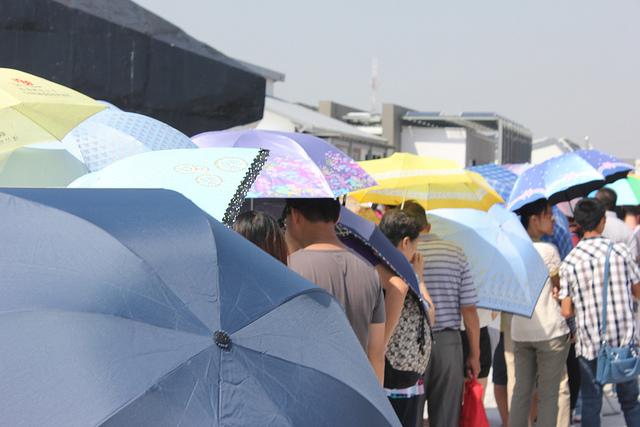How many umbrellas are here?
Be succinct. 10. Are there men and women in the picture?
Write a very short answer. Yes. Is there a red umbrella?
Quick response, please. No. 